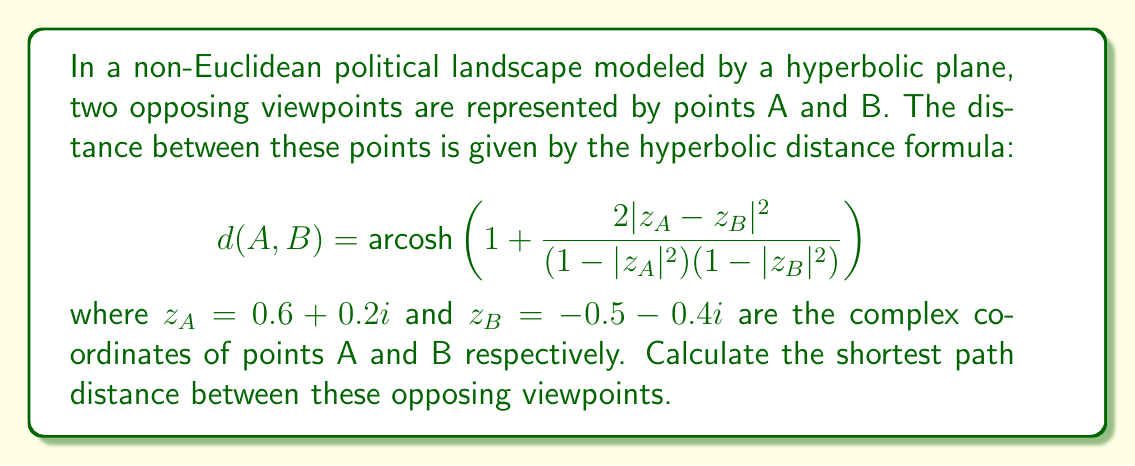Help me with this question. To solve this problem, we'll follow these steps:

1) First, let's calculate $|z_A - z_B|^2$:
   $z_A - z_B = (0.6 + 0.2i) - (-0.5 - 0.4i) = 1.1 + 0.6i$
   $|z_A - z_B|^2 = (1.1)^2 + (0.6)^2 = 1.21 + 0.36 = 1.57$

2) Next, calculate $(1-|z_A|^2)$:
   $|z_A|^2 = (0.6)^2 + (0.2)^2 = 0.36 + 0.04 = 0.4$
   $1-|z_A|^2 = 1 - 0.4 = 0.6$

3) Calculate $(1-|z_B|^2)$:
   $|z_B|^2 = (-0.5)^2 + (-0.4)^2 = 0.25 + 0.16 = 0.41$
   $1-|z_B|^2 = 1 - 0.41 = 0.59$

4) Now we can substitute these values into the formula:
   $$ d(A,B) = \text{arcosh}(1 + \frac{2(1.57)}{(0.6)(0.59)}) $$

5) Simplify:
   $$ d(A,B) = \text{arcosh}(1 + \frac{3.14}{0.354}) = \text{arcosh}(9.87) $$

6) Calculate the final result:
   $d(A,B) \approx 2.89$

Therefore, the shortest path distance between the opposing viewpoints in this non-Euclidean political landscape is approximately 2.89 units.
Answer: $2.89$ units 